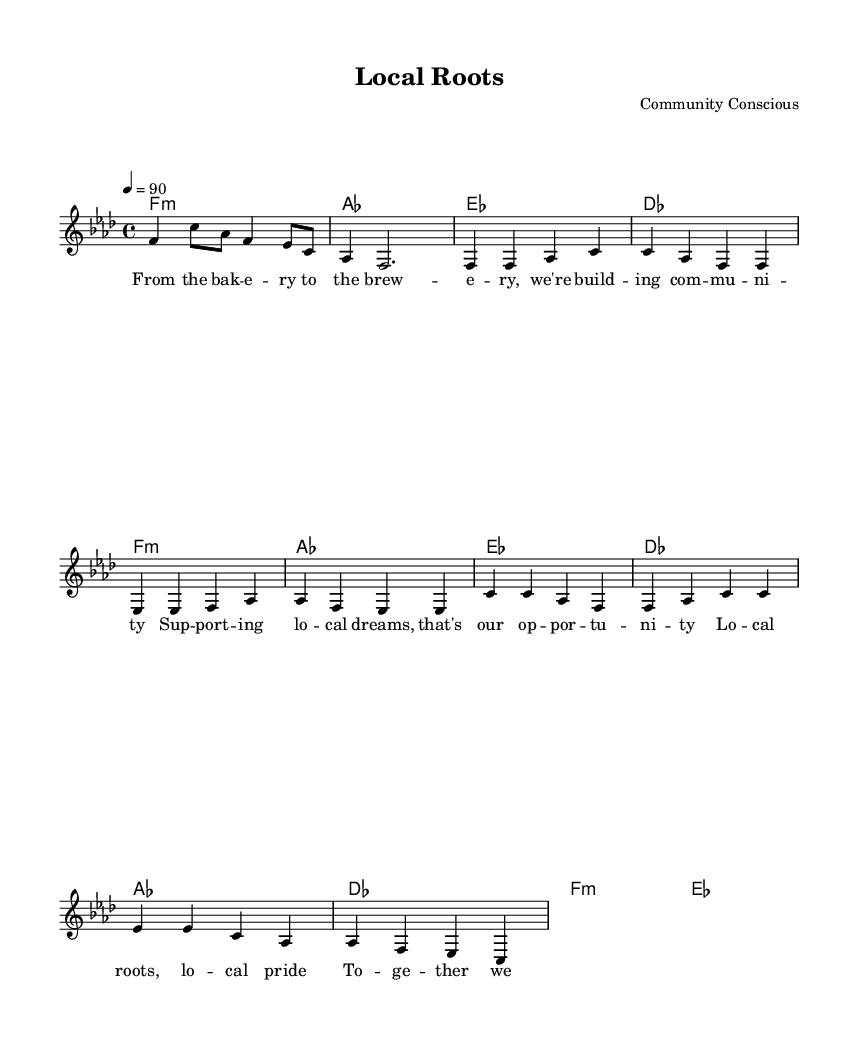What is the key signature of this music? The key signature is F minor, which has four flats indicated at the beginning of the staff.
Answer: F minor What is the time signature of this piece? The time signature, shown at the beginning of the music, is 4/4, which means there are four beats in a measure.
Answer: 4/4 What is the tempo marking of the piece? The tempo marking indicates a speed of 90 beats per minute, shown by the tempo directive in the global section.
Answer: 90 How many measures are in the verse section? Counting the measures in the verse, there are four measures of melody and corresponding harmonies.
Answer: Four What is the primary theme of the lyrics? The lyrics emphasize community building and supporting local enterprises, as highlighted in the verse lyrics.
Answer: Community support What is the form of the song based on the structure? The form consists of a verse followed by a chorus, which is common in hip hop music for delivering messages.
Answer: Verse-Chorus What does the chorus repeat? The catchy phrase in the chorus promotes unity and collective identity, which resonates with hip hop themes.
Answer: Local roots, local pride 